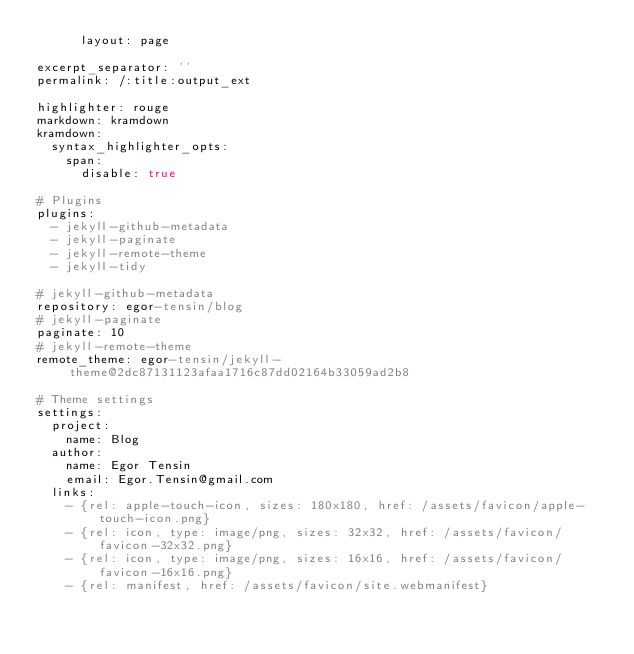<code> <loc_0><loc_0><loc_500><loc_500><_YAML_>      layout: page

excerpt_separator: ''
permalink: /:title:output_ext

highlighter: rouge
markdown: kramdown
kramdown:
  syntax_highlighter_opts:
    span:
      disable: true

# Plugins
plugins:
  - jekyll-github-metadata
  - jekyll-paginate
  - jekyll-remote-theme
  - jekyll-tidy

# jekyll-github-metadata
repository: egor-tensin/blog
# jekyll-paginate
paginate: 10
# jekyll-remote-theme
remote_theme: egor-tensin/jekyll-theme@2dc87131123afaa1716c87dd02164b33059ad2b8

# Theme settings
settings:
  project:
    name: Blog
  author:
    name: Egor Tensin
    email: Egor.Tensin@gmail.com
  links:
    - {rel: apple-touch-icon, sizes: 180x180, href: /assets/favicon/apple-touch-icon.png}
    - {rel: icon, type: image/png, sizes: 32x32, href: /assets/favicon/favicon-32x32.png}
    - {rel: icon, type: image/png, sizes: 16x16, href: /assets/favicon/favicon-16x16.png}
    - {rel: manifest, href: /assets/favicon/site.webmanifest}
</code> 